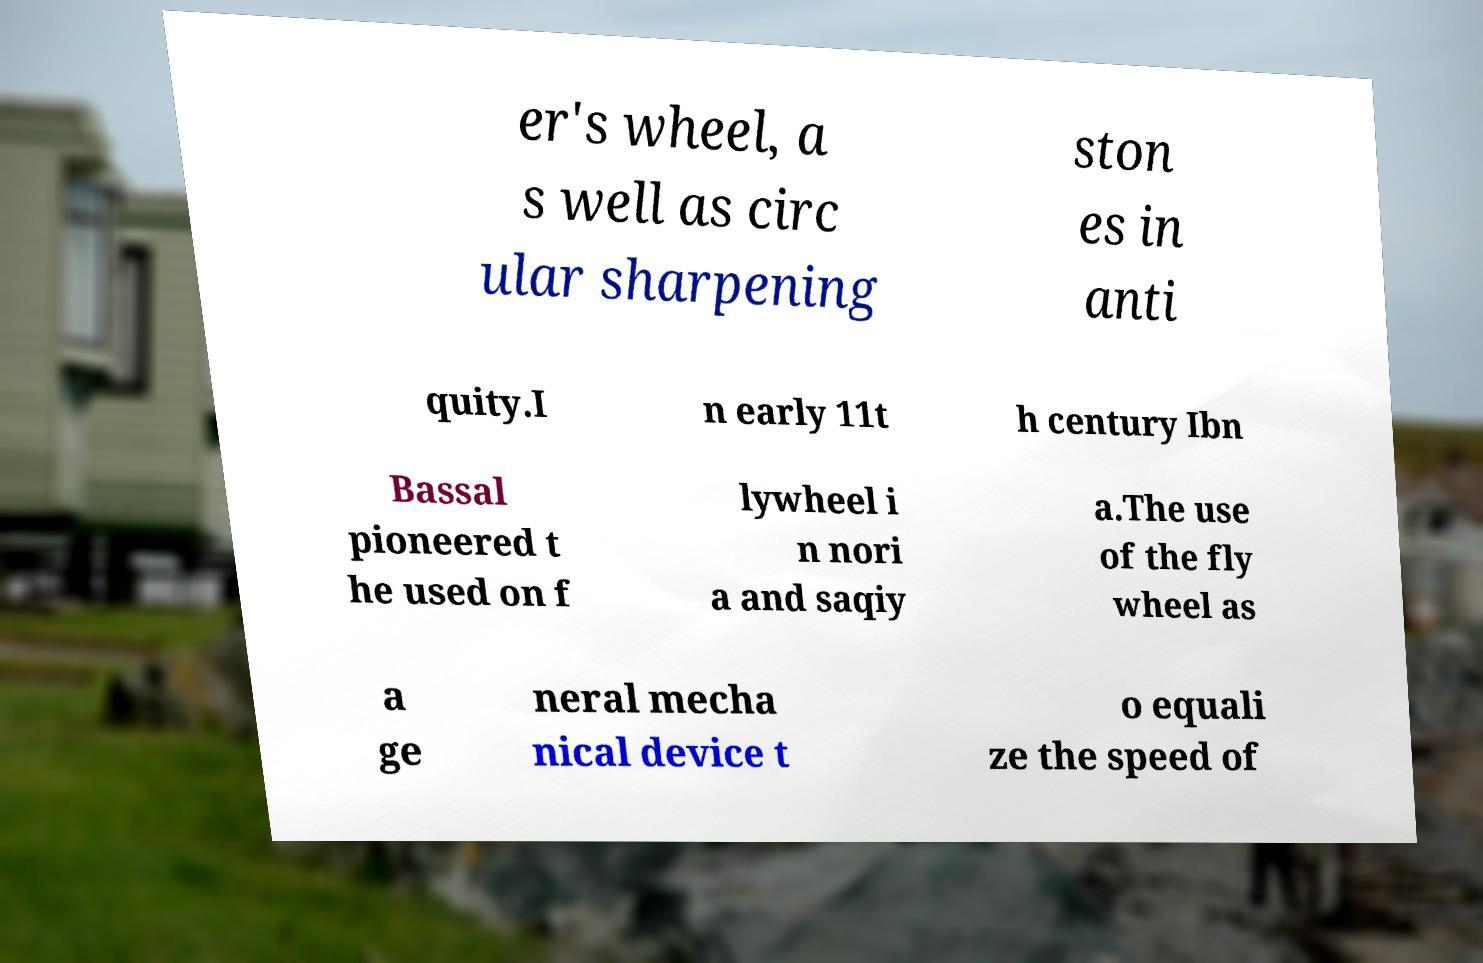For documentation purposes, I need the text within this image transcribed. Could you provide that? er's wheel, a s well as circ ular sharpening ston es in anti quity.I n early 11t h century Ibn Bassal pioneered t he used on f lywheel i n nori a and saqiy a.The use of the fly wheel as a ge neral mecha nical device t o equali ze the speed of 